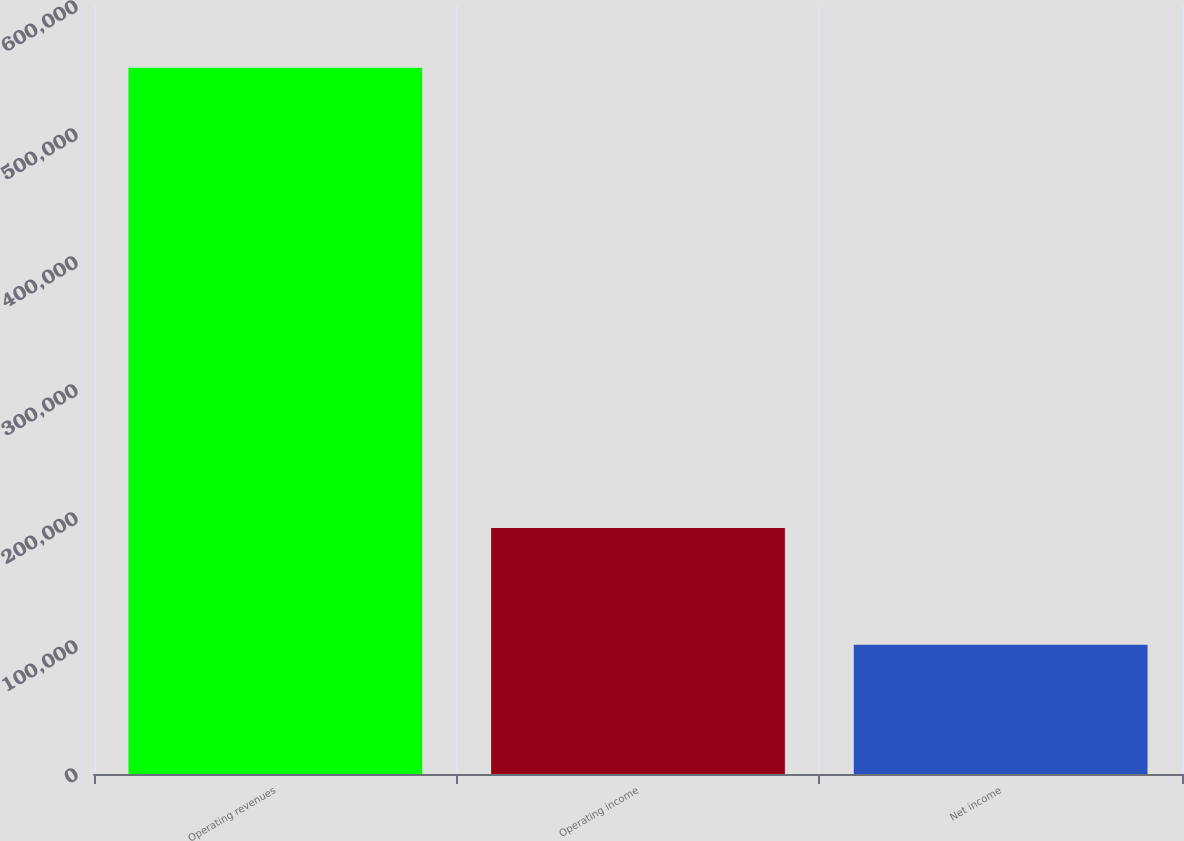<chart> <loc_0><loc_0><loc_500><loc_500><bar_chart><fcel>Operating revenues<fcel>Operating income<fcel>Net income<nl><fcel>551853<fcel>192173<fcel>100926<nl></chart> 